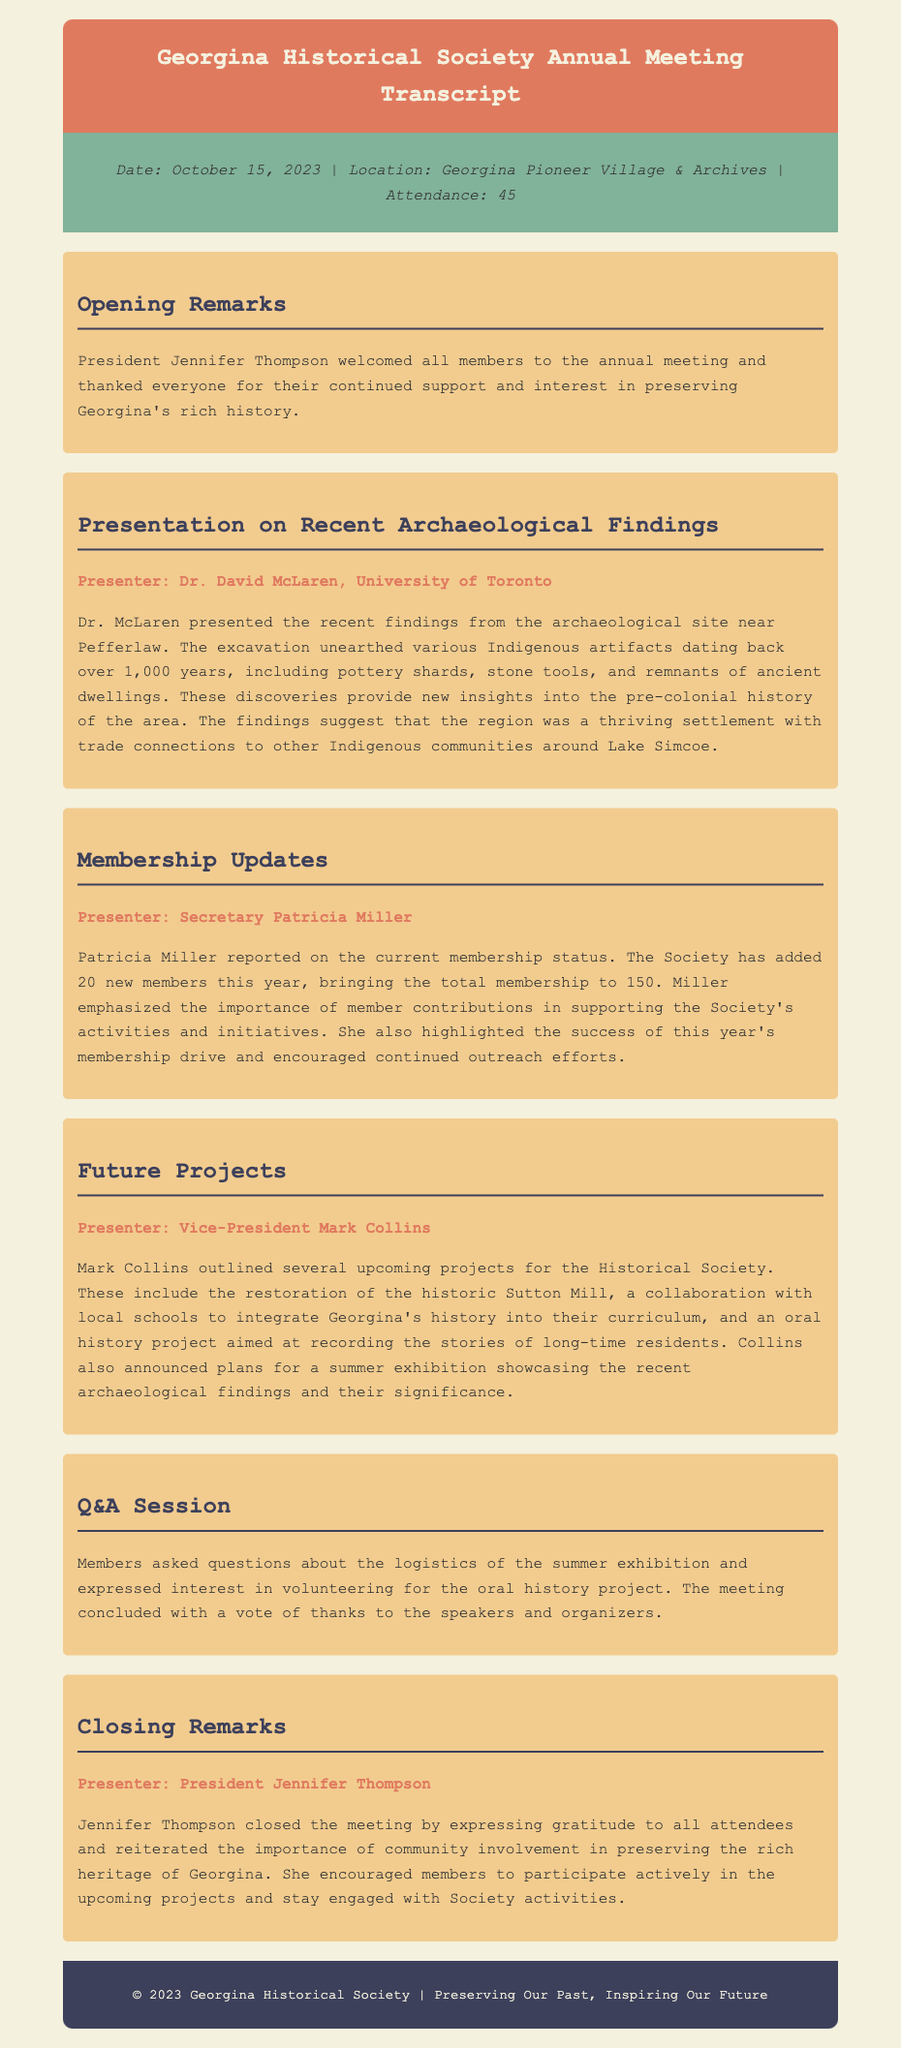What is the date of the annual meeting? The date is mentioned in the meeting information section of the document.
Answer: October 15, 2023 Who presented the archaeological findings? The presenter's name is stated in the section about archaeological findings.
Answer: Dr. David McLaren How many new members were added this year? The number of new members is reported in the membership updates section.
Answer: 20 What project involves collaboration with local schools? This project is outlined in the future projects section, highlighting its educational aspect.
Answer: Integrate Georgina's history into their curriculum What was discussed during the Q&A session? The content of the Q&A session is summarized at the end of the document, highlighting member interest.
Answer: Logistics of the summer exhibition Who welcomed the members at the opening remarks? The name of the person delivering the opening remarks is mentioned at the beginning of the meeting.
Answer: Jennifer Thompson What is the total membership reported? The total membership figure is provided in the membership updates section.
Answer: 150 What is one of the key findings from the archaeological site near Pefferlaw? This detail about the findings is summarized in the archaeological findings section.
Answer: Indigenous artifacts dating back over 1,000 years What is the purpose of the oral history project? The objective of this project is mentioned in the future projects section of the document.
Answer: Recording the stories of long-time residents 